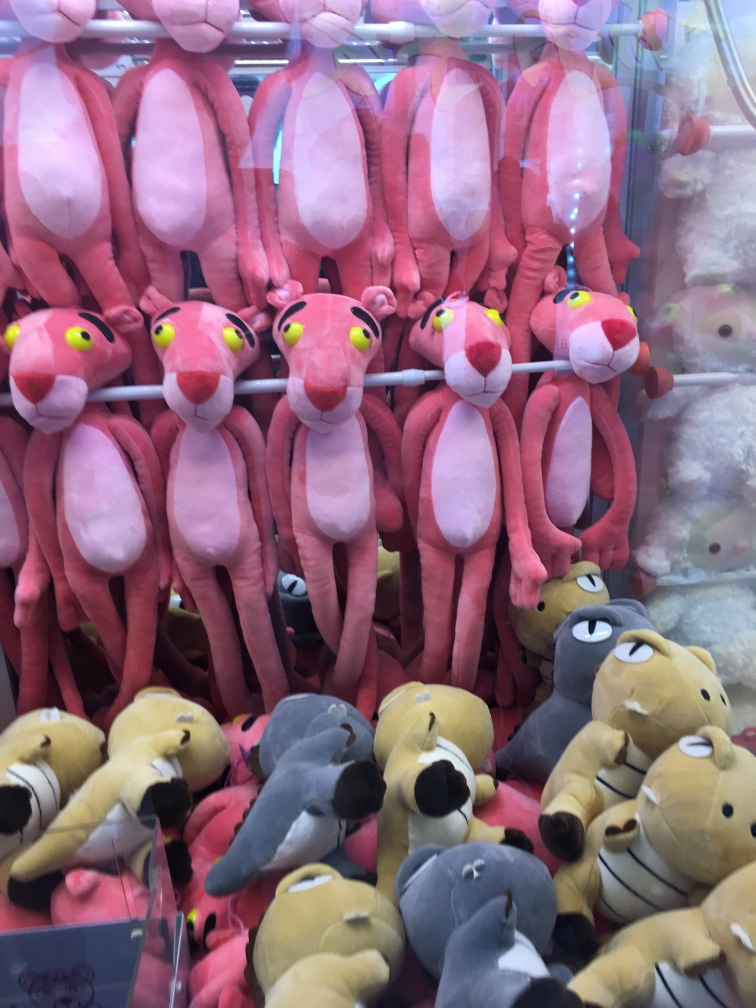Is the background dinosaur blurry? It appears that the focus of the photo is on the plush toys in the front, particularly the pink ones, which are sharp and clear. However, the background does indeed show signs of blurriness, most likely due to the shallow depth of field from the camera. This effect causes the background objects, including any dinosaurs present, to appear less sharp. 